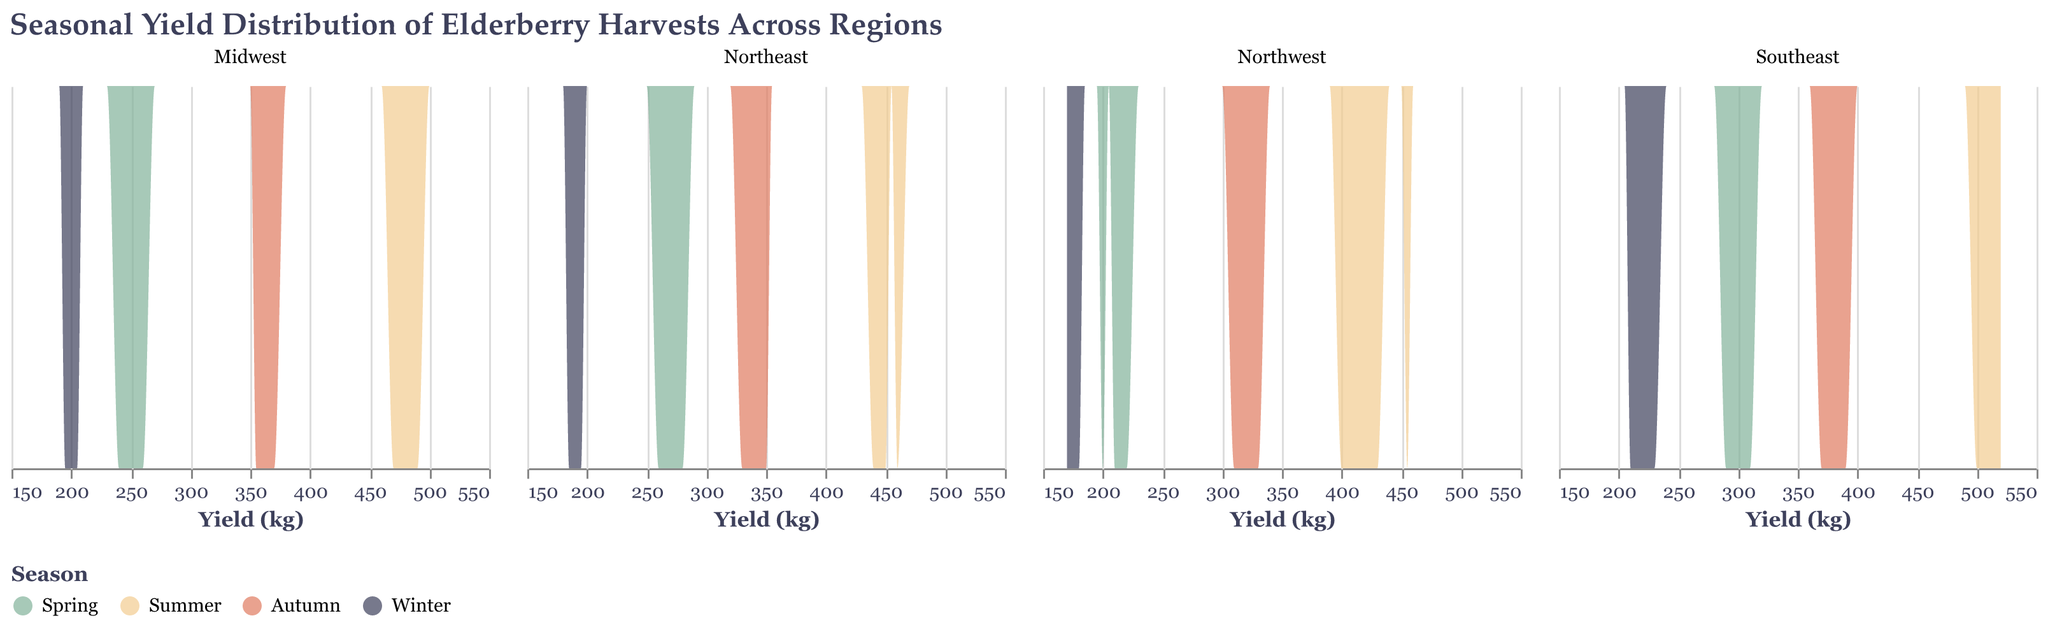What's the title of the figure? The title is generally located at the top of the figure and provides a description of what the figure represents. Here, it says "Seasonal Yield Distribution of Elderberry Harvests Across Regions".
Answer: Seasonal Yield Distribution of Elderberry Harvests Across Regions How many regions are represented in the figure? The regions can be identified by looking at the facets in the subplot, where each facet represents a different region. There are four regions shown: Northwest, Midwest, Southeast, and Northeast.
Answer: 4 What seasons are represented in the color legend? The color legend at the bottom of the figure shows the different seasons represented and their corresponding colors. The seasons are Spring, Summer, Autumn, and Winter.
Answer: Spring, Summer, Autumn, Winter Which region has the highest summer yield peak? To determine which region has the highest summer yield peak, one must compare the peak heights of the summer yield distribution across all regions. The Southeast region has the highest peak during the summer.
Answer: Southeast In the Northwest, how does the yield distribution in winter compare to that in autumn? By examining the density plots in the Northwest region, we see that the yield distribution in winter is lower and less spread out compared to autumn, indicating that yields are generally lower and more consistent in winter.
Answer: Lower in winter What's the range of the elderberry yield in the Midwest during the spring season? Observing the density area for the spring season in the Midwest plot, the yield ranges roughly between 240 kg and 260 kg.
Answer: 240 kg to 260 kg How does the yield distribution in spring in the Southeast region compare to that in the Northeast region? Compare the density plots for spring in both regions. The Southeast has a slightly higher yield in spring, generally around 300 kg, while the Northeast's spring yield centers around 270 kg.
Answer: Southeast is higher Which season has the least variation in yield in the Northeast region? To find the season with the least variation, look for the season with the narrowest and highest peak on the density plot for the Northeast region. Winter has the least variation.
Answer: Winter What is the yield range for the summer season in the Midwest region? Observing the summer season density plot in the Midwest region, the yield ranges from about 470 kg to 490 kg.
Answer: 470 kg to 490 kg How do the yields in autumn compare across all regions? By analyzing the density plots for autumn across all regions, we observe that yields in the Southeast and Midwest are higher compared to the Northwest and Northeast.
Answer: Southeast and Midwest are higher 